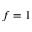<formula> <loc_0><loc_0><loc_500><loc_500>f = 1</formula> 